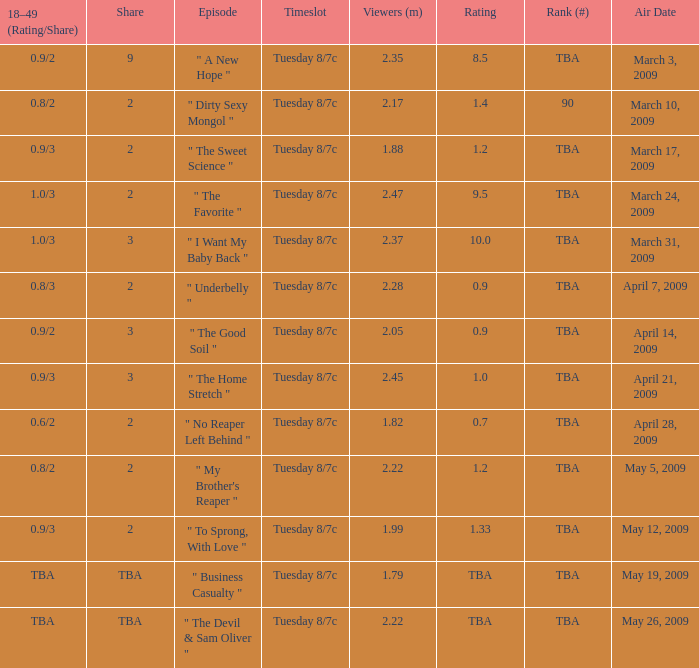8/3? 2.0. 